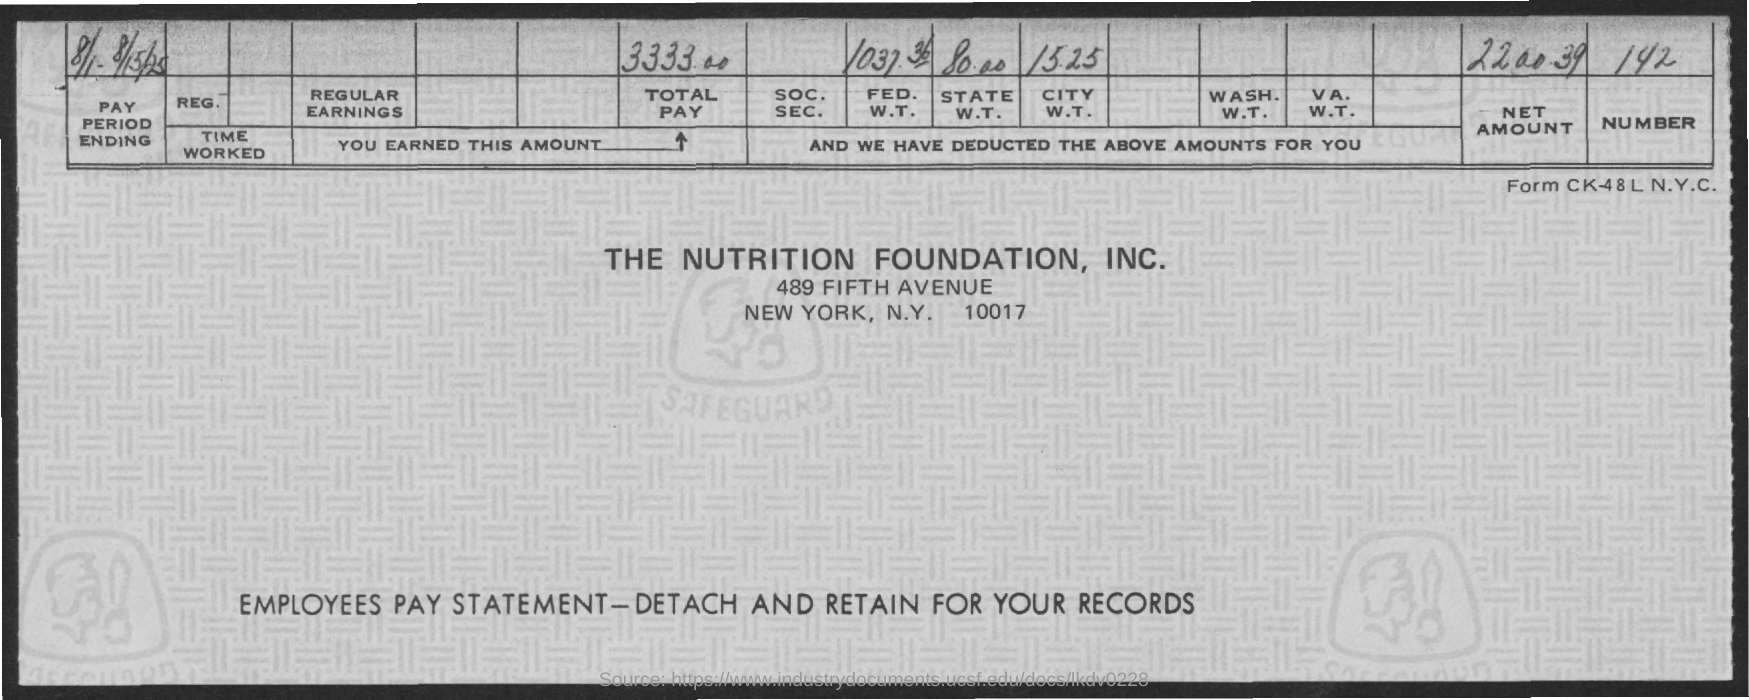Identify some key points in this picture. The net amount mentioned on the given page is 2,200.39. The amount for state W.T. mentioned in the given page is 80.00. The total pay mentioned in the given page is 3333.00. What is the amount for City W.T. as mentioned in the given page?" The amount is 15.25. According to the provided page, the amount for FED. W.T. is 1037.36. 